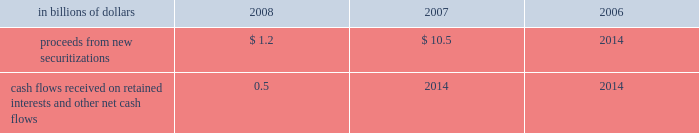Application of specific accounting literature .
For the nonconsolidated proprietary tob trusts and qspe tob trusts , the company recognizes only its residual investment on its balance sheet at fair value and the third-party financing raised by the trusts is off-balance sheet .
The table summarizes selected cash flow information related to municipal bond securitizations for the years 2008 , 2007 and 2006 : in billions of dollars 2008 2007 2006 .
Cash flows received on retained interests and other net cash flows 0.5 2014 2014 municipal investments municipal investment transactions represent partnerships that finance the construction and rehabilitation of low-income affordable rental housing .
The company generally invests in these partnerships as a limited partner and earns a return primarily through the receipt of tax credits earned from the affordable housing investments made by the partnership .
Client intermediation client intermediation transactions represent a range of transactions designed to provide investors with specified returns based on the returns of an underlying security , referenced asset or index .
These transactions include credit-linked notes and equity-linked notes .
In these transactions , the spe typically obtains exposure to the underlying security , referenced asset or index through a derivative instrument , such as a total-return swap or a credit-default swap .
In turn the spe issues notes to investors that pay a return based on the specified underlying security , referenced asset or index .
The spe invests the proceeds in a financial asset or a guaranteed insurance contract ( gic ) that serves as collateral for the derivative contract over the term of the transaction .
The company 2019s involvement in these transactions includes being the counterparty to the spe 2019s derivative instruments and investing in a portion of the notes issued by the spe .
In certain transactions , the investor 2019s maximum risk of loss is limited and the company absorbs risk of loss above a specified level .
The company 2019s maximum risk of loss in these transactions is defined as the amount invested in notes issued by the spe and the notional amount of any risk of loss absorbed by the company through a separate instrument issued by the spe .
The derivative instrument held by the company may generate a receivable from the spe ( for example , where the company purchases credit protection from the spe in connection with the spe 2019s issuance of a credit-linked note ) , which is collateralized by the assets owned by the spe .
These derivative instruments are not considered variable interests under fin 46 ( r ) and any associated receivables are not included in the calculation of maximum exposure to the spe .
Structured investment vehicles structured investment vehicles ( sivs ) are spes that issue junior notes and senior debt ( medium-term notes and short-term commercial paper ) to fund the purchase of high quality assets .
The junior notes are subject to the 201cfirst loss 201d risk of the sivs .
The sivs provide a variable return to the junior note investors based on the net spread between the cost to issue the senior debt and the return realized by the high quality assets .
The company acts as manager for the sivs and , prior to december 13 , 2007 , was not contractually obligated to provide liquidity facilities or guarantees to the sivs .
In response to the ratings review of the outstanding senior debt of the sivs for a possible downgrade announced by two ratings agencies and the continued reduction of liquidity in the siv-related asset-backed commercial paper and medium-term note markets , on december 13 , 2007 , citigroup announced its commitment to provide support facilities that would support the sivs 2019 senior debt ratings .
As a result of this commitment , citigroup became the sivs 2019 primary beneficiary and began consolidating these entities .
On february 12 , 2008 , citigroup finalized the terms of the support facilities , which took the form of a commitment to provide $ 3.5 billion of mezzanine capital to the sivs in the event the market value of their junior notes approaches zero .
The mezzanine capital facility was increased by $ 1 billion to $ 4.5 billion , with the additional commitment funded during the fourth quarter of 2008 .
The facilities rank senior to the junior notes but junior to the commercial paper and medium-term notes .
The facilities were at arm 2019s-length terms .
Interest was paid on the drawn amount of the facilities and a per annum fee was paid on the unused portion .
During the period to november 18 , 2008 , the company wrote down $ 3.3 billion on siv assets .
In order to complete the wind-down of the sivs , the company , in a nearly cashless transaction , purchased the remaining assets of the sivs at fair value , with a trade date of november 18 , 2008 .
The company funded the purchase of the siv assets by assuming the obligation to pay amounts due under the medium-term notes issued by the sivs , as the medium-term notes mature .
The net funding provided by the company to fund the purchase of the siv assets was $ 0.3 billion .
As of december 31 , 2008 , the carrying amount of the purchased siv assets was $ 16.6 billion , of which $ 16.5 billion is classified as htm assets .
Investment funds the company is the investment manager for certain investment funds that invest in various asset classes including private equity , hedge funds , real estate , fixed income and infrastructure .
The company earns a management fee , which is a percentage of capital under management , and may earn performance fees .
In addition , for some of these funds the company has an ownership interest in the investment funds .
The company has also established a number of investment funds as opportunities for qualified employees to invest in private equity investments .
The company acts as investment manager to these funds and may provide employees with financing on both a recourse and non-recourse basis for a portion of the employees 2019 investment commitments. .
In 2008 what was the percentage increased in the mezzanine capital facility? 
Computations: (1 / (4.5 - 1))
Answer: 0.28571. 